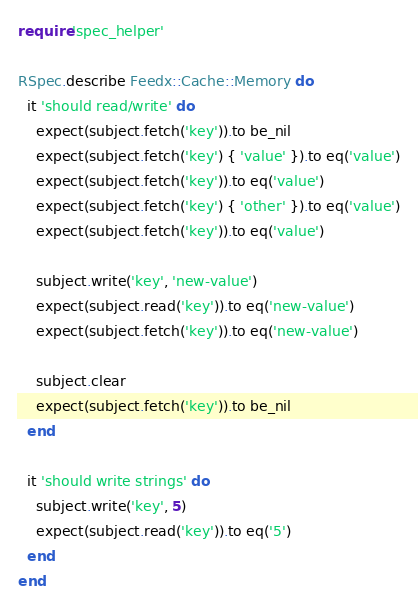Convert code to text. <code><loc_0><loc_0><loc_500><loc_500><_Ruby_>require 'spec_helper'

RSpec.describe Feedx::Cache::Memory do
  it 'should read/write' do
    expect(subject.fetch('key')).to be_nil
    expect(subject.fetch('key') { 'value' }).to eq('value')
    expect(subject.fetch('key')).to eq('value')
    expect(subject.fetch('key') { 'other' }).to eq('value')
    expect(subject.fetch('key')).to eq('value')

    subject.write('key', 'new-value')
    expect(subject.read('key')).to eq('new-value')
    expect(subject.fetch('key')).to eq('new-value')

    subject.clear
    expect(subject.fetch('key')).to be_nil
  end

  it 'should write strings' do
    subject.write('key', 5)
    expect(subject.read('key')).to eq('5')
  end
end
</code> 